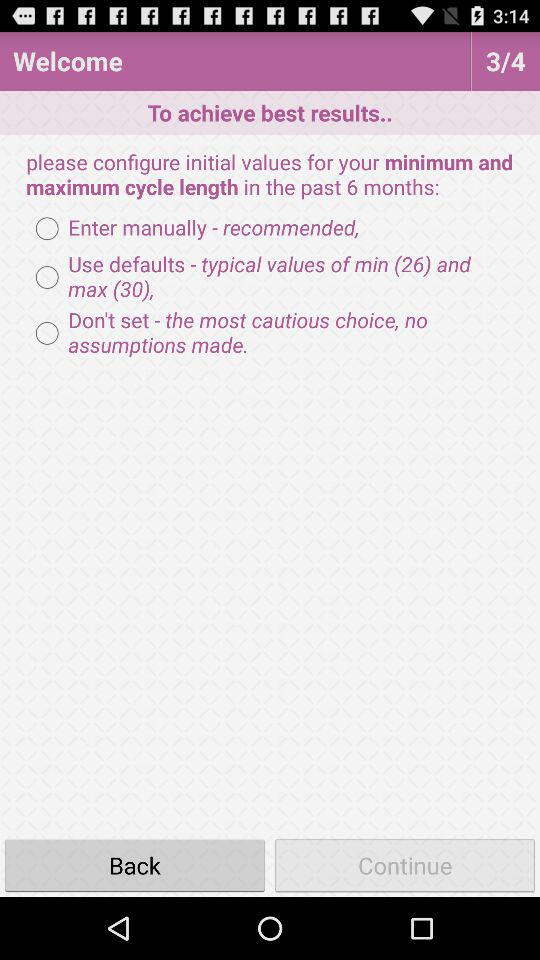What is the typical value for the maximum cycle length? The typical value for the maximum cycle length is 30. 